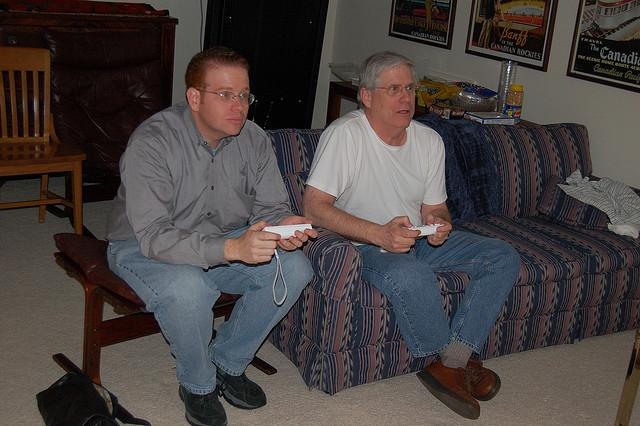What is the name of the white device in the men's hands? Please explain your reasoning. game controller. A father and son are sitting on the couch playing with a wii remote. 